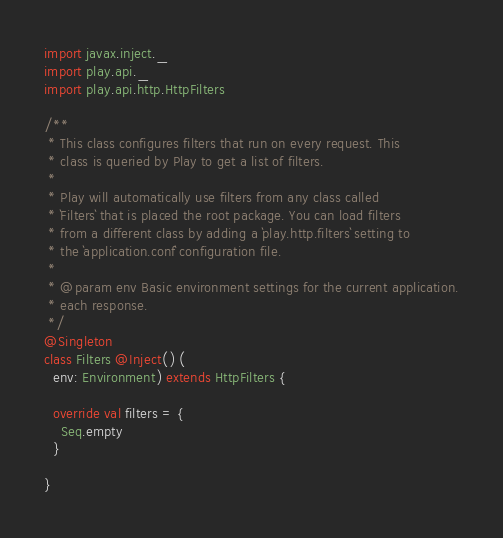<code> <loc_0><loc_0><loc_500><loc_500><_Scala_>import javax.inject._
import play.api._
import play.api.http.HttpFilters

/**
 * This class configures filters that run on every request. This
 * class is queried by Play to get a list of filters.
 *
 * Play will automatically use filters from any class called
 * `Filters` that is placed the root package. You can load filters
 * from a different class by adding a `play.http.filters` setting to
 * the `application.conf` configuration file.
 *
 * @param env Basic environment settings for the current application.
 * each response.
 */
@Singleton
class Filters @Inject() (
  env: Environment) extends HttpFilters {

  override val filters = {
    Seq.empty
  }

}
</code> 